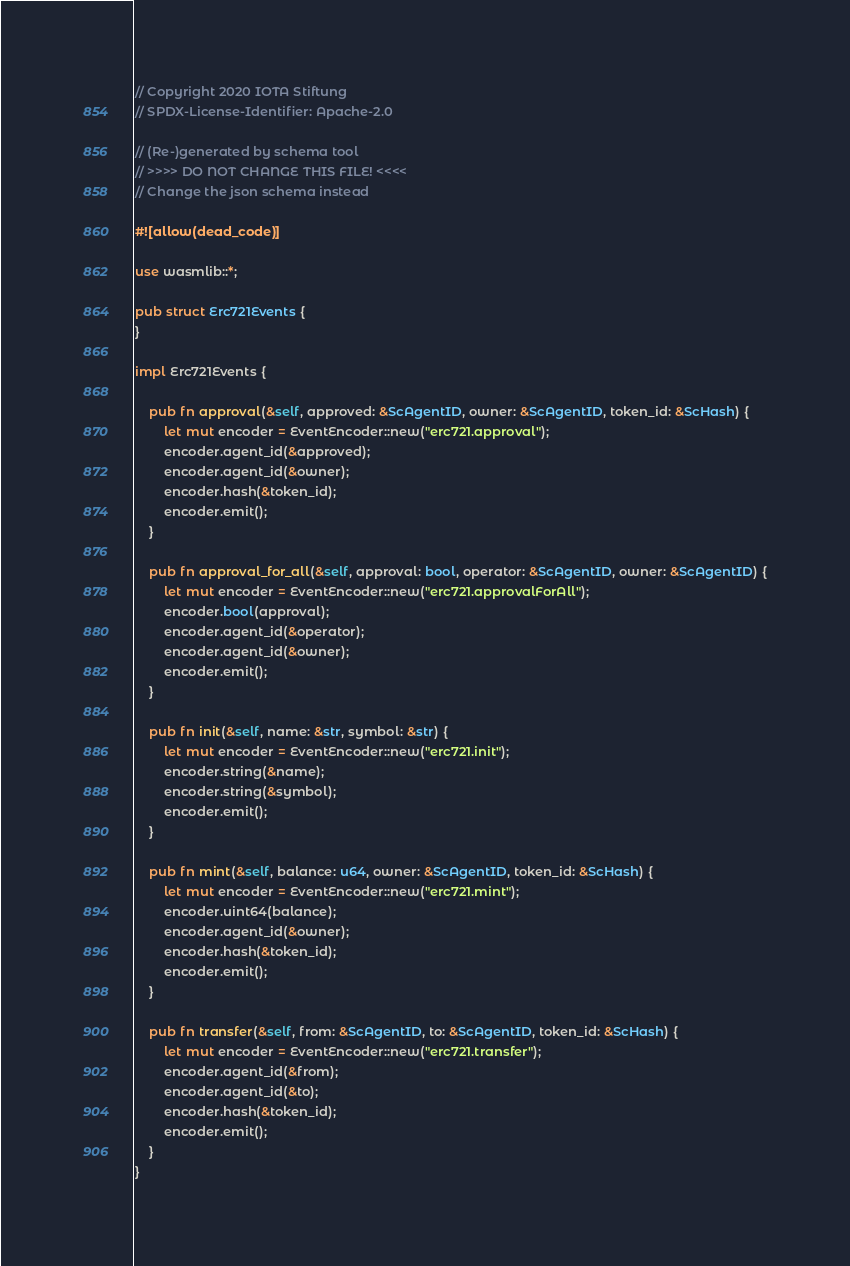Convert code to text. <code><loc_0><loc_0><loc_500><loc_500><_Rust_>// Copyright 2020 IOTA Stiftung
// SPDX-License-Identifier: Apache-2.0

// (Re-)generated by schema tool
// >>>> DO NOT CHANGE THIS FILE! <<<<
// Change the json schema instead

#![allow(dead_code)]

use wasmlib::*;

pub struct Erc721Events {
}

impl Erc721Events {

	pub fn approval(&self, approved: &ScAgentID, owner: &ScAgentID, token_id: &ScHash) {
		let mut encoder = EventEncoder::new("erc721.approval");
		encoder.agent_id(&approved);
		encoder.agent_id(&owner);
		encoder.hash(&token_id);
		encoder.emit();
	}

	pub fn approval_for_all(&self, approval: bool, operator: &ScAgentID, owner: &ScAgentID) {
		let mut encoder = EventEncoder::new("erc721.approvalForAll");
		encoder.bool(approval);
		encoder.agent_id(&operator);
		encoder.agent_id(&owner);
		encoder.emit();
	}

	pub fn init(&self, name: &str, symbol: &str) {
		let mut encoder = EventEncoder::new("erc721.init");
		encoder.string(&name);
		encoder.string(&symbol);
		encoder.emit();
	}

	pub fn mint(&self, balance: u64, owner: &ScAgentID, token_id: &ScHash) {
		let mut encoder = EventEncoder::new("erc721.mint");
		encoder.uint64(balance);
		encoder.agent_id(&owner);
		encoder.hash(&token_id);
		encoder.emit();
	}

	pub fn transfer(&self, from: &ScAgentID, to: &ScAgentID, token_id: &ScHash) {
		let mut encoder = EventEncoder::new("erc721.transfer");
		encoder.agent_id(&from);
		encoder.agent_id(&to);
		encoder.hash(&token_id);
		encoder.emit();
	}
}
</code> 